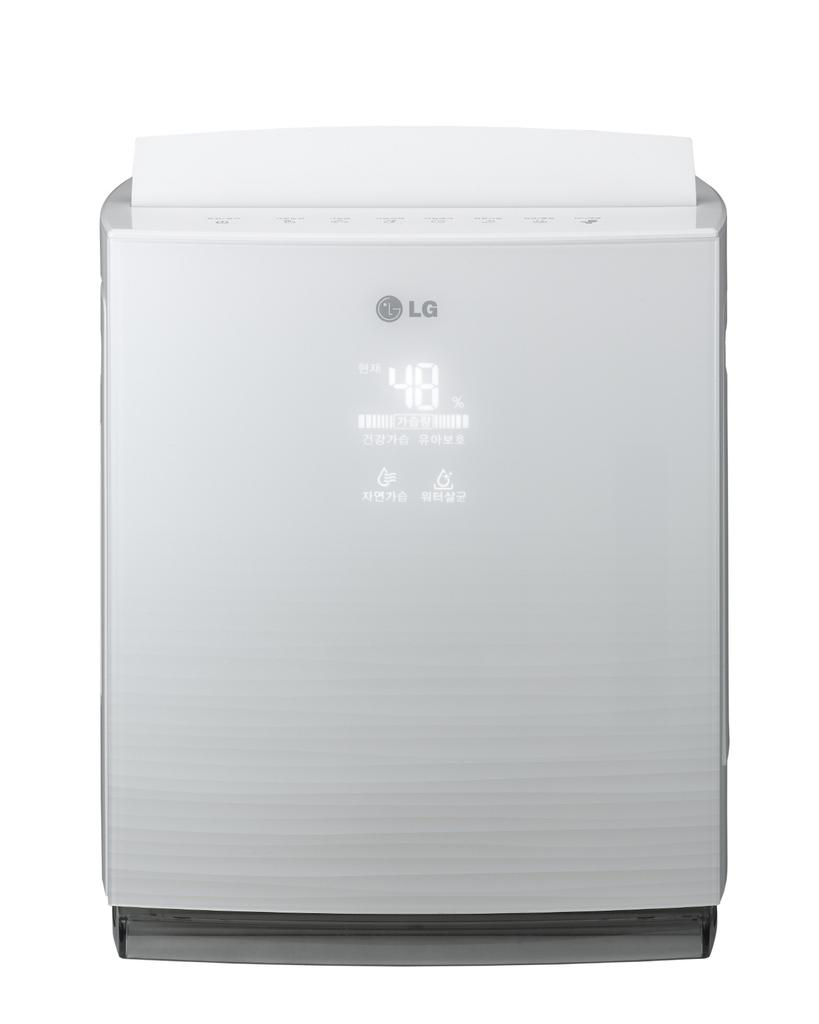<image>
Give a short and clear explanation of the subsequent image. the LG device says 48 degrees on the front of it 